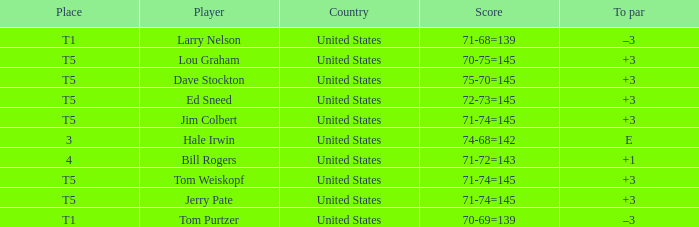Who is the player with a 70-75=145 score? Lou Graham. 